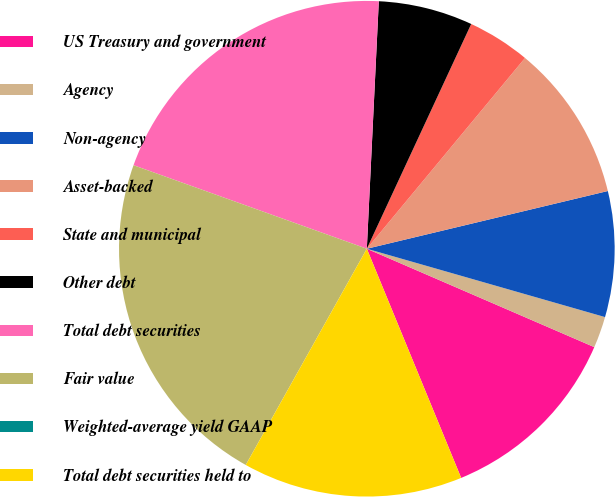Convert chart to OTSL. <chart><loc_0><loc_0><loc_500><loc_500><pie_chart><fcel>US Treasury and government<fcel>Agency<fcel>Non-agency<fcel>Asset-backed<fcel>State and municipal<fcel>Other debt<fcel>Total debt securities<fcel>Fair value<fcel>Weighted-average yield GAAP<fcel>Total debt securities held to<nl><fcel>12.29%<fcel>2.05%<fcel>8.19%<fcel>10.24%<fcel>4.1%<fcel>6.15%<fcel>20.3%<fcel>22.35%<fcel>0.0%<fcel>14.34%<nl></chart> 